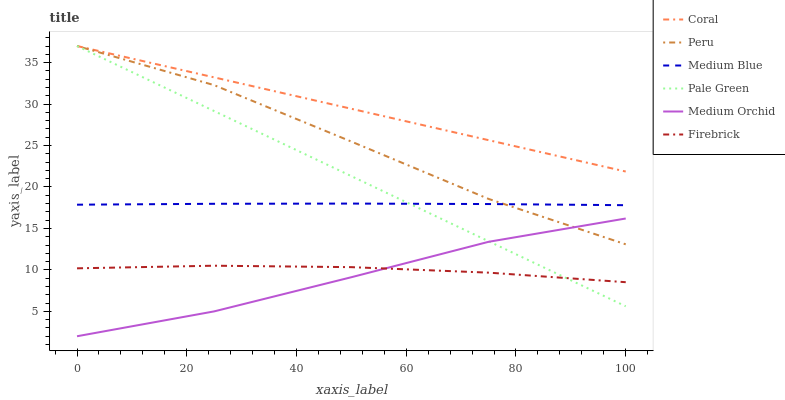Does Medium Blue have the minimum area under the curve?
Answer yes or no. No. Does Medium Blue have the maximum area under the curve?
Answer yes or no. No. Is Medium Orchid the smoothest?
Answer yes or no. No. Is Medium Orchid the roughest?
Answer yes or no. No. Does Medium Blue have the lowest value?
Answer yes or no. No. Does Medium Orchid have the highest value?
Answer yes or no. No. Is Medium Orchid less than Coral?
Answer yes or no. Yes. Is Medium Blue greater than Firebrick?
Answer yes or no. Yes. Does Medium Orchid intersect Coral?
Answer yes or no. No. 